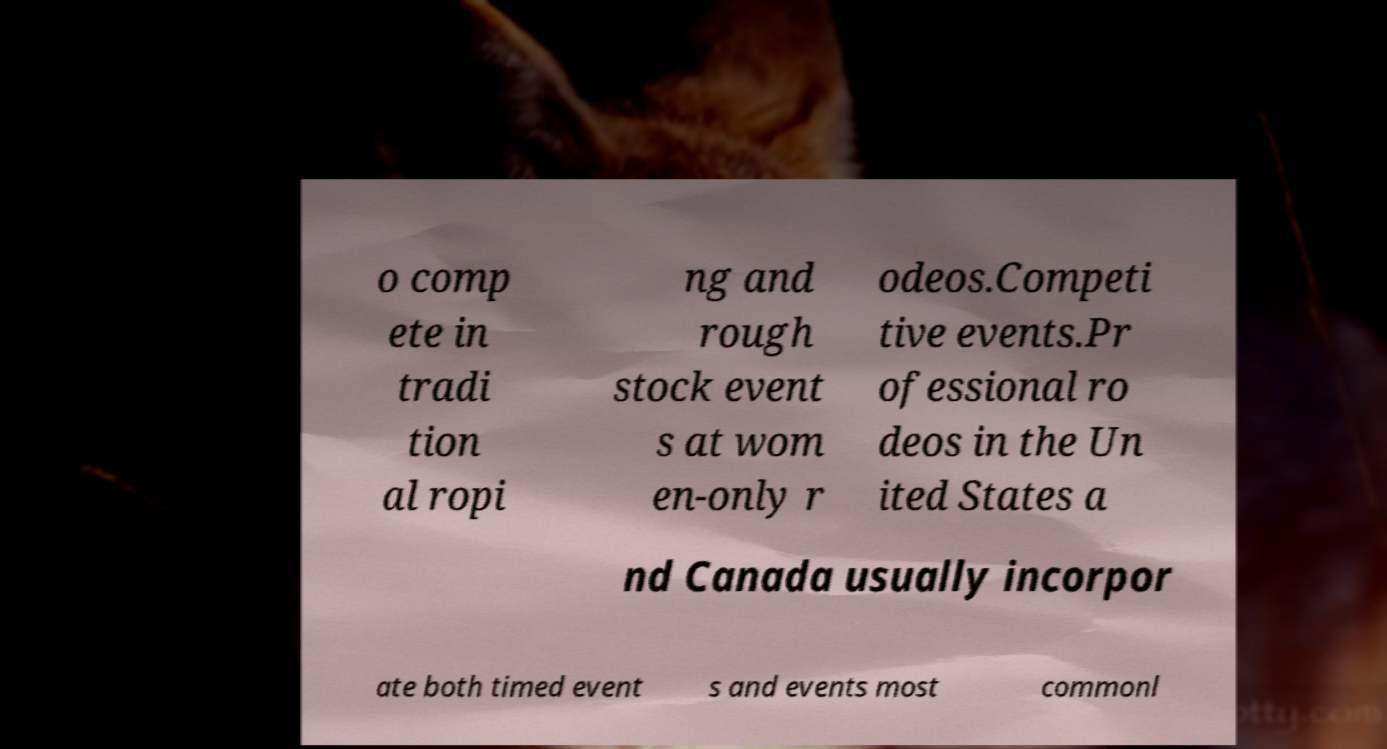Could you extract and type out the text from this image? o comp ete in tradi tion al ropi ng and rough stock event s at wom en-only r odeos.Competi tive events.Pr ofessional ro deos in the Un ited States a nd Canada usually incorpor ate both timed event s and events most commonl 